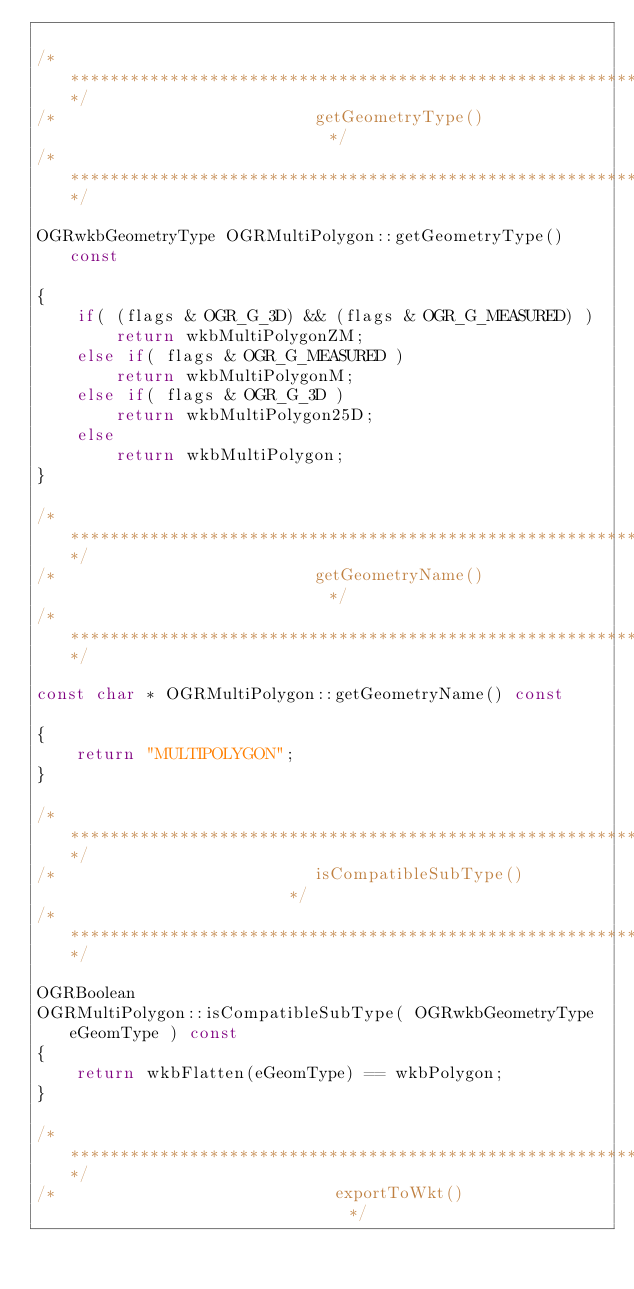<code> <loc_0><loc_0><loc_500><loc_500><_C++_>
/************************************************************************/
/*                          getGeometryType()                           */
/************************************************************************/

OGRwkbGeometryType OGRMultiPolygon::getGeometryType() const

{
    if( (flags & OGR_G_3D) && (flags & OGR_G_MEASURED) )
        return wkbMultiPolygonZM;
    else if( flags & OGR_G_MEASURED )
        return wkbMultiPolygonM;
    else if( flags & OGR_G_3D )
        return wkbMultiPolygon25D;
    else
        return wkbMultiPolygon;
}

/************************************************************************/
/*                          getGeometryName()                           */
/************************************************************************/

const char * OGRMultiPolygon::getGeometryName() const

{
    return "MULTIPOLYGON";
}

/************************************************************************/
/*                          isCompatibleSubType()                       */
/************************************************************************/

OGRBoolean
OGRMultiPolygon::isCompatibleSubType( OGRwkbGeometryType eGeomType ) const
{
    return wkbFlatten(eGeomType) == wkbPolygon;
}

/************************************************************************/
/*                            exportToWkt()                             */</code> 